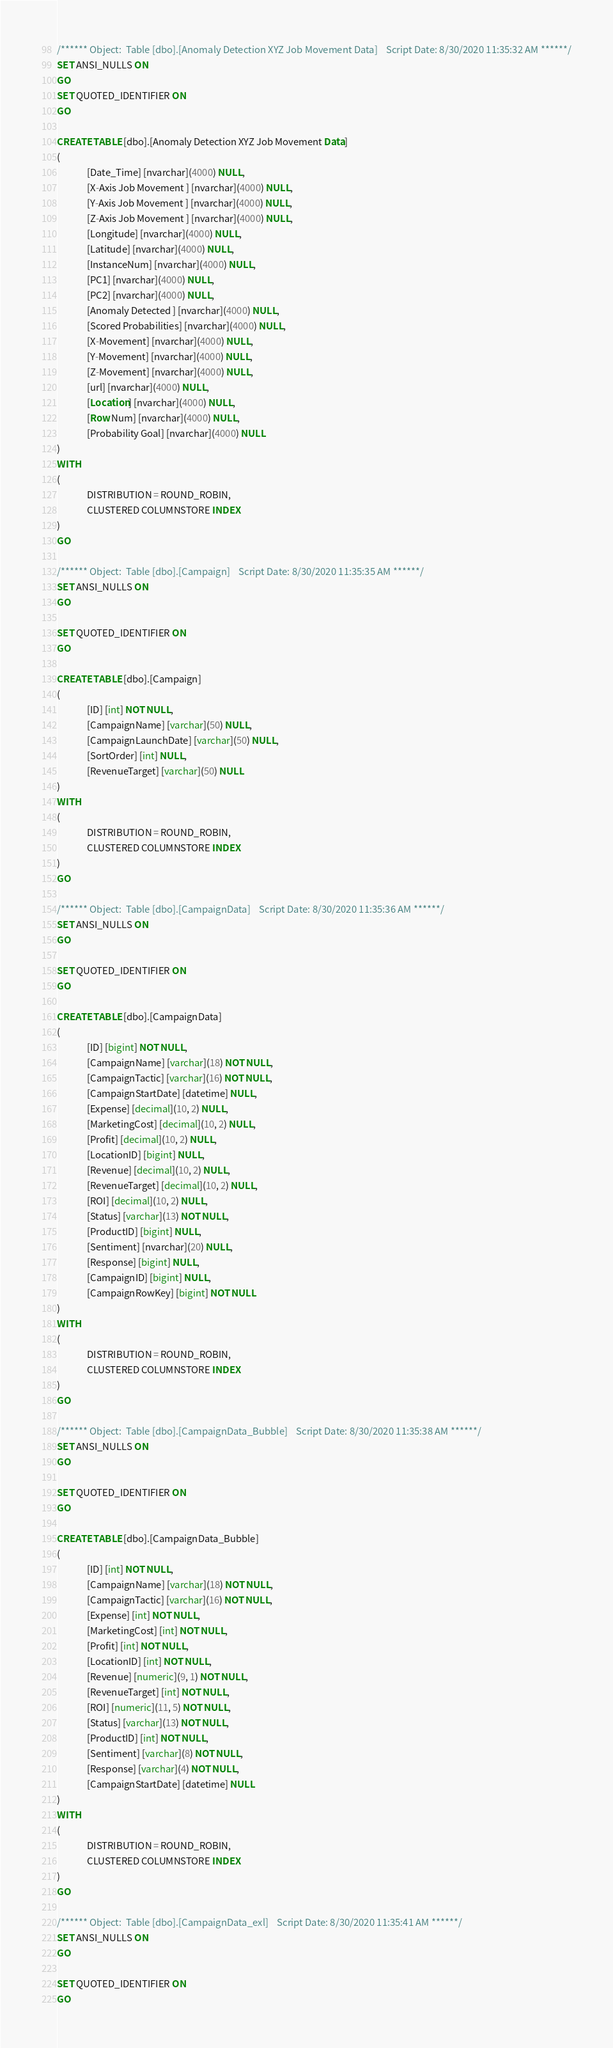Convert code to text. <code><loc_0><loc_0><loc_500><loc_500><_SQL_>
/****** Object:  Table [dbo].[Anomaly Detection XYZ Job Movement Data]    Script Date: 8/30/2020 11:35:32 AM ******/
SET ANSI_NULLS ON
GO 
SET QUOTED_IDENTIFIER ON
GO

CREATE TABLE [dbo].[Anomaly Detection XYZ Job Movement Data]
(
              [Date_Time] [nvarchar](4000) NULL,
              [X-Axis Job Movement ] [nvarchar](4000) NULL,
              [Y-Axis Job Movement ] [nvarchar](4000) NULL,
              [Z-Axis Job Movement ] [nvarchar](4000) NULL,
              [Longitude] [nvarchar](4000) NULL,
              [Latitude] [nvarchar](4000) NULL,
              [InstanceNum] [nvarchar](4000) NULL,
              [PC1] [nvarchar](4000) NULL,
              [PC2] [nvarchar](4000) NULL,
              [Anomaly Detected ] [nvarchar](4000) NULL,
              [Scored Probabilities] [nvarchar](4000) NULL,
              [X-Movement] [nvarchar](4000) NULL,
              [Y-Movement] [nvarchar](4000) NULL,
              [Z-Movement] [nvarchar](4000) NULL,
              [url] [nvarchar](4000) NULL,
              [Location] [nvarchar](4000) NULL,
              [Row Num] [nvarchar](4000) NULL,
              [Probability Goal] [nvarchar](4000) NULL
)
WITH
(
              DISTRIBUTION = ROUND_ROBIN,
              CLUSTERED COLUMNSTORE INDEX
)
GO

/****** Object:  Table [dbo].[Campaign]    Script Date: 8/30/2020 11:35:35 AM ******/
SET ANSI_NULLS ON
GO

SET QUOTED_IDENTIFIER ON
GO

CREATE TABLE [dbo].[Campaign]
(
              [ID] [int] NOT NULL,
              [CampaignName] [varchar](50) NULL,
              [CampaignLaunchDate] [varchar](50) NULL,
              [SortOrder] [int] NULL,
              [RevenueTarget] [varchar](50) NULL
)
WITH
(
              DISTRIBUTION = ROUND_ROBIN,
              CLUSTERED COLUMNSTORE INDEX
)
GO

/****** Object:  Table [dbo].[CampaignData]    Script Date: 8/30/2020 11:35:36 AM ******/
SET ANSI_NULLS ON
GO

SET QUOTED_IDENTIFIER ON
GO

CREATE TABLE [dbo].[CampaignData]
(
              [ID] [bigint] NOT NULL,
              [CampaignName] [varchar](18) NOT NULL,
              [CampaignTactic] [varchar](16) NOT NULL,
              [CampaignStartDate] [datetime] NULL,
              [Expense] [decimal](10, 2) NULL,
              [MarketingCost] [decimal](10, 2) NULL,
              [Profit] [decimal](10, 2) NULL,
              [LocationID] [bigint] NULL,
              [Revenue] [decimal](10, 2) NULL,
              [RevenueTarget] [decimal](10, 2) NULL,
              [ROI] [decimal](10, 2) NULL,
              [Status] [varchar](13) NOT NULL,
              [ProductID] [bigint] NULL,
              [Sentiment] [nvarchar](20) NULL,
              [Response] [bigint] NULL,
              [CampaignID] [bigint] NULL,
              [CampaignRowKey] [bigint] NOT NULL
)
WITH
(
              DISTRIBUTION = ROUND_ROBIN,
              CLUSTERED COLUMNSTORE INDEX
)
GO

/****** Object:  Table [dbo].[CampaignData_Bubble]    Script Date: 8/30/2020 11:35:38 AM ******/
SET ANSI_NULLS ON
GO

SET QUOTED_IDENTIFIER ON
GO

CREATE TABLE [dbo].[CampaignData_Bubble]
(
              [ID] [int] NOT NULL,
              [CampaignName] [varchar](18) NOT NULL,
              [CampaignTactic] [varchar](16) NOT NULL,
              [Expense] [int] NOT NULL,
              [MarketingCost] [int] NOT NULL,
              [Profit] [int] NOT NULL,
              [LocationID] [int] NOT NULL,
              [Revenue] [numeric](9, 1) NOT NULL,
              [RevenueTarget] [int] NOT NULL,
              [ROI] [numeric](11, 5) NOT NULL,
              [Status] [varchar](13) NOT NULL,
              [ProductID] [int] NOT NULL,
              [Sentiment] [varchar](8) NOT NULL,
              [Response] [varchar](4) NOT NULL,
              [CampaignStartDate] [datetime] NULL
)
WITH
(
              DISTRIBUTION = ROUND_ROBIN,
              CLUSTERED COLUMNSTORE INDEX
)
GO

/****** Object:  Table [dbo].[CampaignData_exl]    Script Date: 8/30/2020 11:35:41 AM ******/
SET ANSI_NULLS ON
GO

SET QUOTED_IDENTIFIER ON
GO
</code> 